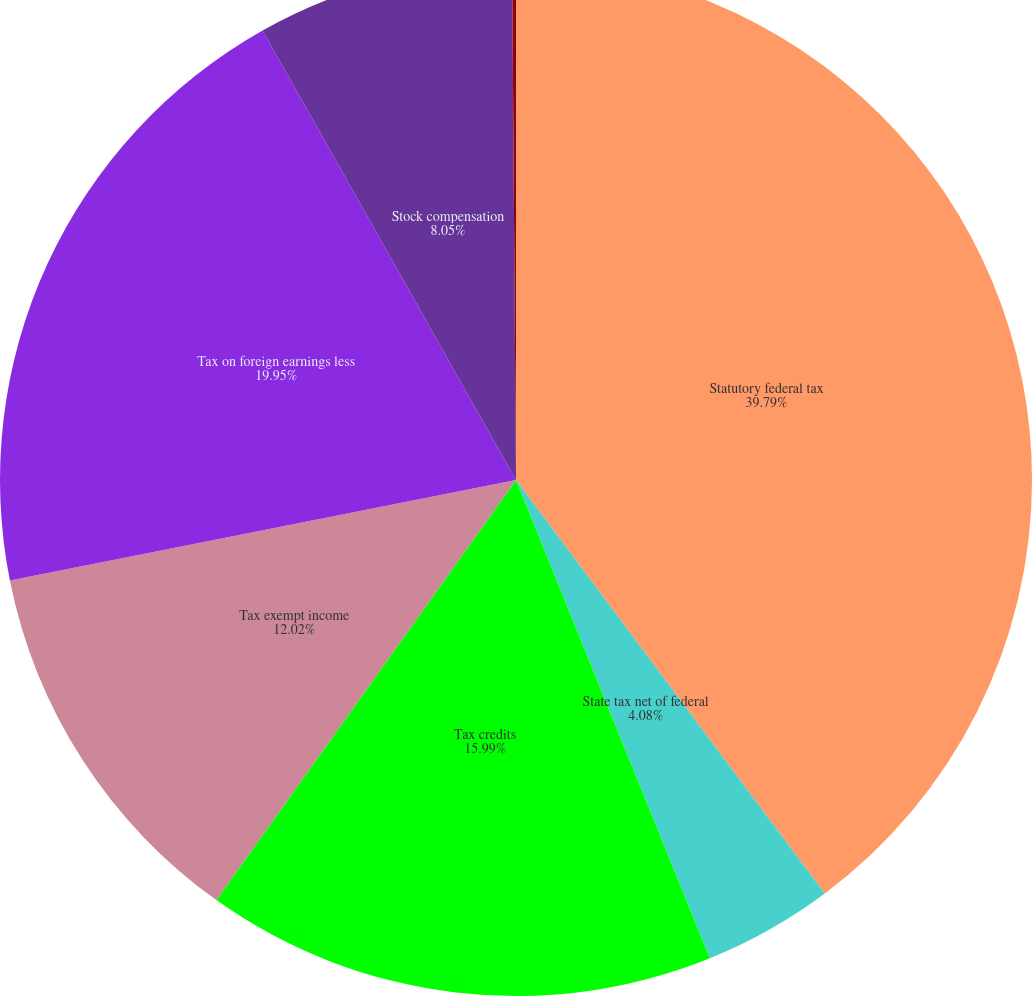Convert chart. <chart><loc_0><loc_0><loc_500><loc_500><pie_chart><fcel>Statutory federal tax<fcel>State tax net of federal<fcel>Tax credits<fcel>Tax exempt income<fcel>Tax on foreign earnings less<fcel>Stock compensation<fcel>Other<nl><fcel>39.79%<fcel>4.08%<fcel>15.99%<fcel>12.02%<fcel>19.95%<fcel>8.05%<fcel>0.12%<nl></chart> 